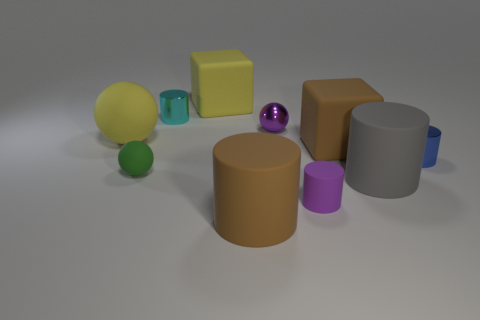How many big yellow rubber spheres are in front of the gray matte thing that is behind the large brown cylinder? There are no big yellow rubber spheres located in front of the gray matte object, which is situated behind the large brown cylinder. The scene includes various objects of different shapes and colors, but none match the description of a big yellow rubber sphere in that particular location. 